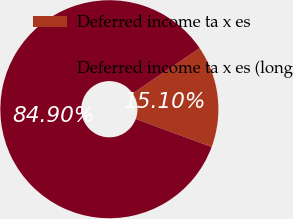Convert chart to OTSL. <chart><loc_0><loc_0><loc_500><loc_500><pie_chart><fcel>Deferred income ta x es<fcel>Deferred income ta x es (long<nl><fcel>15.1%<fcel>84.9%<nl></chart> 